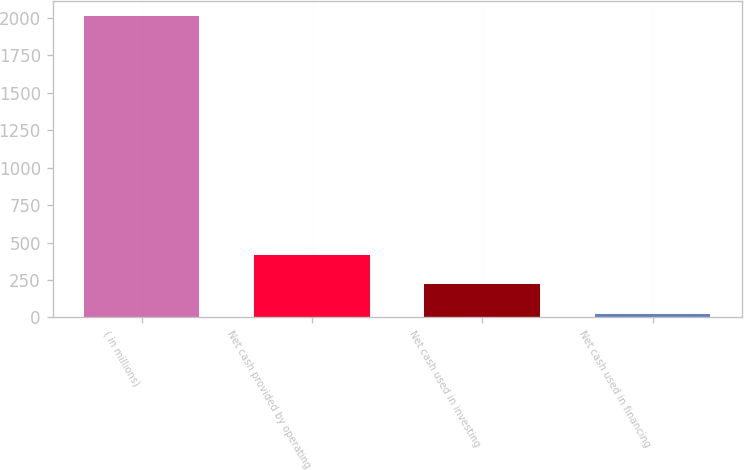<chart> <loc_0><loc_0><loc_500><loc_500><bar_chart><fcel>( in millions)<fcel>Net cash provided by operating<fcel>Net cash used in investing<fcel>Net cash used in financing<nl><fcel>2009<fcel>419.88<fcel>221.24<fcel>22.6<nl></chart> 